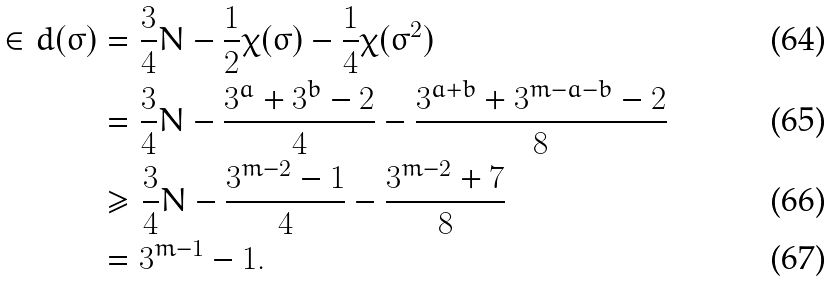Convert formula to latex. <formula><loc_0><loc_0><loc_500><loc_500>\in d ( \sigma ) & = \frac { 3 } { 4 } N - \frac { 1 } { 2 } \chi ( \sigma ) - \frac { 1 } { 4 } \chi ( \sigma ^ { 2 } ) \\ & = \frac { 3 } { 4 } N - \frac { 3 ^ { a } + 3 ^ { b } - 2 } { 4 } - \frac { 3 ^ { a + b } + 3 ^ { m - a - b } - 2 } { 8 } \\ & \geq \frac { 3 } { 4 } N - \frac { 3 ^ { m - 2 } - 1 } { 4 } - \frac { 3 ^ { m - 2 } + 7 } { 8 } \\ & = 3 ^ { m - 1 } - 1 .</formula> 